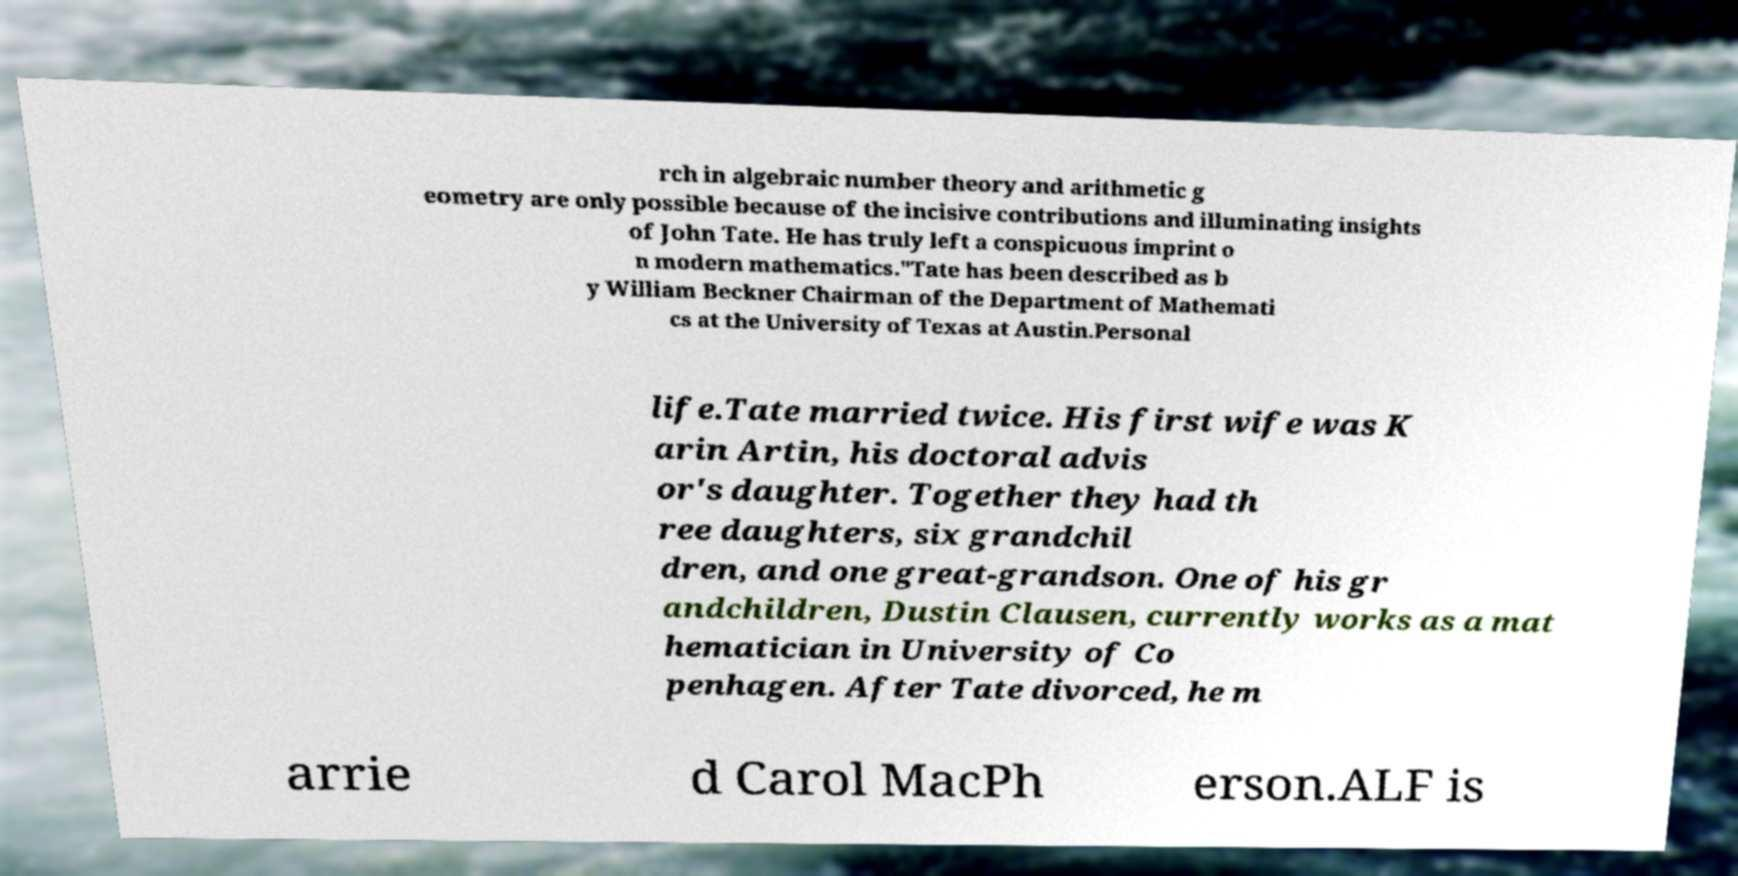Could you assist in decoding the text presented in this image and type it out clearly? rch in algebraic number theory and arithmetic g eometry are only possible because of the incisive contributions and illuminating insights of John Tate. He has truly left a conspicuous imprint o n modern mathematics."Tate has been described as b y William Beckner Chairman of the Department of Mathemati cs at the University of Texas at Austin.Personal life.Tate married twice. His first wife was K arin Artin, his doctoral advis or's daughter. Together they had th ree daughters, six grandchil dren, and one great-grandson. One of his gr andchildren, Dustin Clausen, currently works as a mat hematician in University of Co penhagen. After Tate divorced, he m arrie d Carol MacPh erson.ALF is 